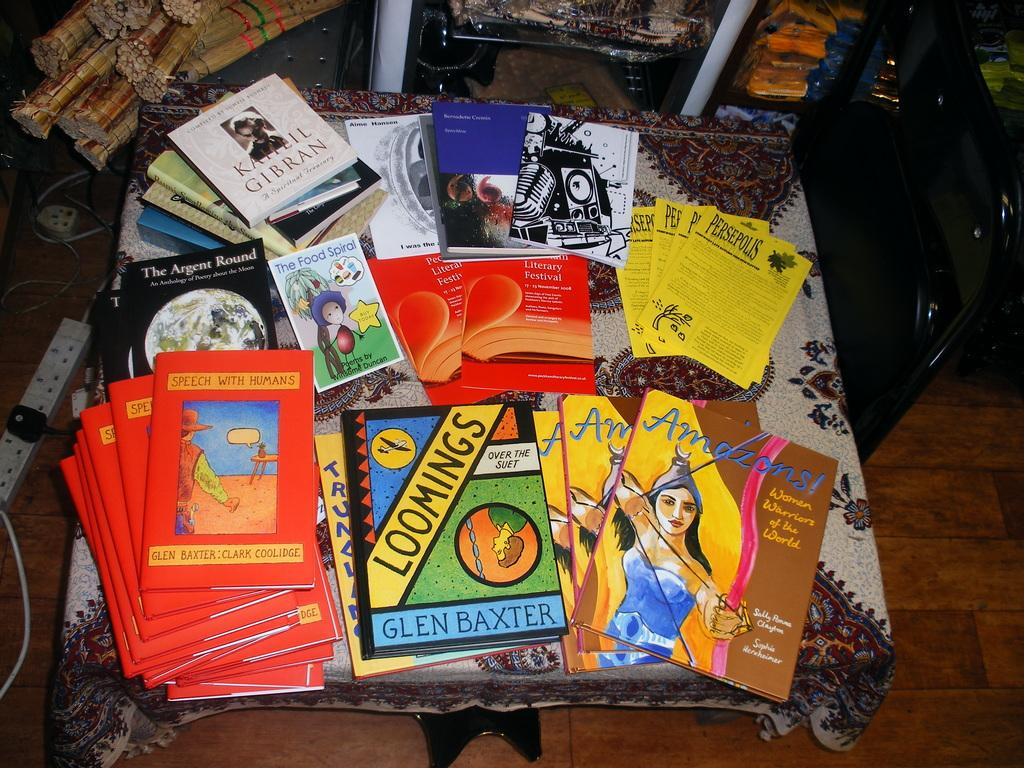<image>
Offer a succinct explanation of the picture presented. A table full of assorted books includes a couple of titles by Glen Baxter. 